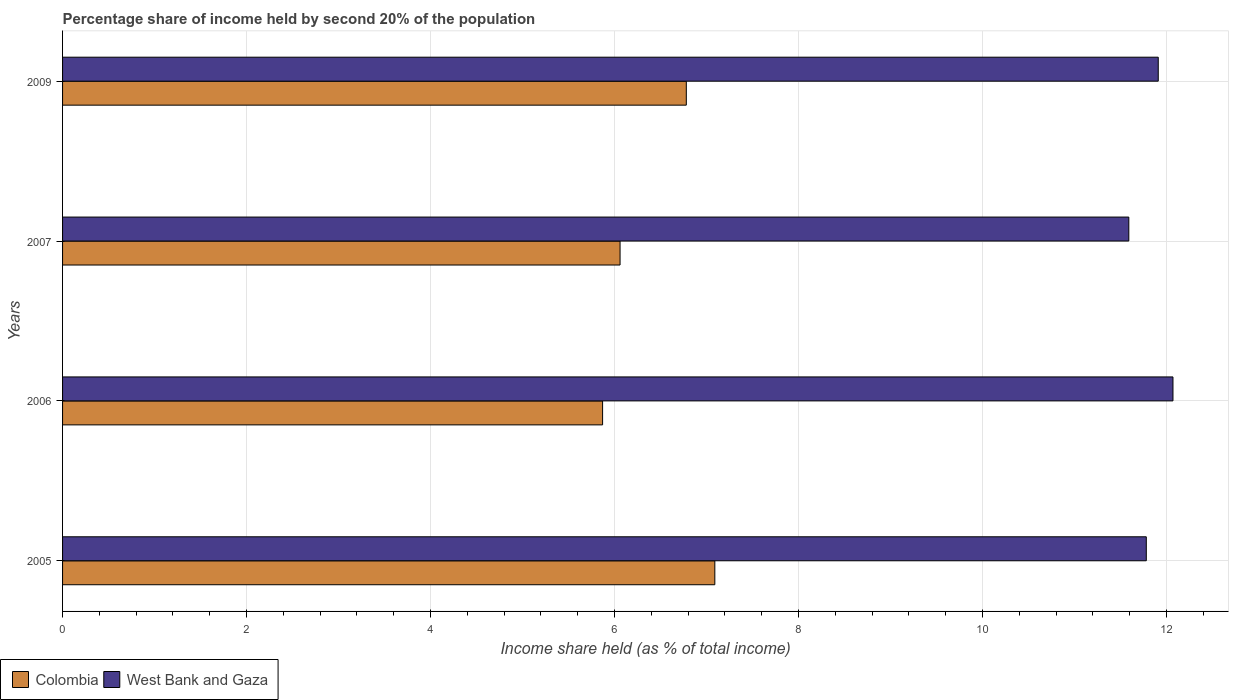How many different coloured bars are there?
Offer a very short reply. 2. What is the label of the 1st group of bars from the top?
Keep it short and to the point. 2009. In how many cases, is the number of bars for a given year not equal to the number of legend labels?
Offer a terse response. 0. What is the share of income held by second 20% of the population in West Bank and Gaza in 2007?
Offer a very short reply. 11.59. Across all years, what is the maximum share of income held by second 20% of the population in Colombia?
Offer a very short reply. 7.09. Across all years, what is the minimum share of income held by second 20% of the population in Colombia?
Make the answer very short. 5.87. In which year was the share of income held by second 20% of the population in Colombia maximum?
Provide a succinct answer. 2005. In which year was the share of income held by second 20% of the population in Colombia minimum?
Your response must be concise. 2006. What is the total share of income held by second 20% of the population in Colombia in the graph?
Offer a terse response. 25.8. What is the difference between the share of income held by second 20% of the population in West Bank and Gaza in 2007 and that in 2009?
Give a very brief answer. -0.32. What is the difference between the share of income held by second 20% of the population in Colombia in 2006 and the share of income held by second 20% of the population in West Bank and Gaza in 2007?
Offer a very short reply. -5.72. What is the average share of income held by second 20% of the population in West Bank and Gaza per year?
Your answer should be very brief. 11.84. In the year 2007, what is the difference between the share of income held by second 20% of the population in West Bank and Gaza and share of income held by second 20% of the population in Colombia?
Offer a very short reply. 5.53. In how many years, is the share of income held by second 20% of the population in Colombia greater than 1.2000000000000002 %?
Provide a succinct answer. 4. What is the ratio of the share of income held by second 20% of the population in Colombia in 2005 to that in 2009?
Provide a short and direct response. 1.05. Is the share of income held by second 20% of the population in Colombia in 2006 less than that in 2009?
Your answer should be compact. Yes. What is the difference between the highest and the second highest share of income held by second 20% of the population in Colombia?
Your answer should be compact. 0.31. What is the difference between the highest and the lowest share of income held by second 20% of the population in West Bank and Gaza?
Keep it short and to the point. 0.48. What does the 2nd bar from the bottom in 2006 represents?
Offer a very short reply. West Bank and Gaza. What is the difference between two consecutive major ticks on the X-axis?
Ensure brevity in your answer.  2. Are the values on the major ticks of X-axis written in scientific E-notation?
Make the answer very short. No. Does the graph contain grids?
Your answer should be very brief. Yes. Where does the legend appear in the graph?
Give a very brief answer. Bottom left. How many legend labels are there?
Offer a very short reply. 2. What is the title of the graph?
Make the answer very short. Percentage share of income held by second 20% of the population. Does "Switzerland" appear as one of the legend labels in the graph?
Provide a succinct answer. No. What is the label or title of the X-axis?
Make the answer very short. Income share held (as % of total income). What is the Income share held (as % of total income) of Colombia in 2005?
Offer a very short reply. 7.09. What is the Income share held (as % of total income) in West Bank and Gaza in 2005?
Make the answer very short. 11.78. What is the Income share held (as % of total income) of Colombia in 2006?
Your answer should be very brief. 5.87. What is the Income share held (as % of total income) of West Bank and Gaza in 2006?
Your response must be concise. 12.07. What is the Income share held (as % of total income) of Colombia in 2007?
Keep it short and to the point. 6.06. What is the Income share held (as % of total income) of West Bank and Gaza in 2007?
Your answer should be very brief. 11.59. What is the Income share held (as % of total income) of Colombia in 2009?
Give a very brief answer. 6.78. What is the Income share held (as % of total income) in West Bank and Gaza in 2009?
Provide a short and direct response. 11.91. Across all years, what is the maximum Income share held (as % of total income) of Colombia?
Ensure brevity in your answer.  7.09. Across all years, what is the maximum Income share held (as % of total income) in West Bank and Gaza?
Provide a succinct answer. 12.07. Across all years, what is the minimum Income share held (as % of total income) in Colombia?
Ensure brevity in your answer.  5.87. Across all years, what is the minimum Income share held (as % of total income) in West Bank and Gaza?
Provide a short and direct response. 11.59. What is the total Income share held (as % of total income) of Colombia in the graph?
Offer a terse response. 25.8. What is the total Income share held (as % of total income) in West Bank and Gaza in the graph?
Offer a terse response. 47.35. What is the difference between the Income share held (as % of total income) of Colombia in 2005 and that in 2006?
Your answer should be compact. 1.22. What is the difference between the Income share held (as % of total income) in West Bank and Gaza in 2005 and that in 2006?
Give a very brief answer. -0.29. What is the difference between the Income share held (as % of total income) of Colombia in 2005 and that in 2007?
Ensure brevity in your answer.  1.03. What is the difference between the Income share held (as % of total income) in West Bank and Gaza in 2005 and that in 2007?
Make the answer very short. 0.19. What is the difference between the Income share held (as % of total income) of Colombia in 2005 and that in 2009?
Keep it short and to the point. 0.31. What is the difference between the Income share held (as % of total income) in West Bank and Gaza in 2005 and that in 2009?
Your answer should be compact. -0.13. What is the difference between the Income share held (as % of total income) of Colombia in 2006 and that in 2007?
Your answer should be very brief. -0.19. What is the difference between the Income share held (as % of total income) in West Bank and Gaza in 2006 and that in 2007?
Ensure brevity in your answer.  0.48. What is the difference between the Income share held (as % of total income) in Colombia in 2006 and that in 2009?
Your answer should be compact. -0.91. What is the difference between the Income share held (as % of total income) of West Bank and Gaza in 2006 and that in 2009?
Offer a terse response. 0.16. What is the difference between the Income share held (as % of total income) in Colombia in 2007 and that in 2009?
Make the answer very short. -0.72. What is the difference between the Income share held (as % of total income) of West Bank and Gaza in 2007 and that in 2009?
Give a very brief answer. -0.32. What is the difference between the Income share held (as % of total income) in Colombia in 2005 and the Income share held (as % of total income) in West Bank and Gaza in 2006?
Provide a short and direct response. -4.98. What is the difference between the Income share held (as % of total income) in Colombia in 2005 and the Income share held (as % of total income) in West Bank and Gaza in 2009?
Provide a short and direct response. -4.82. What is the difference between the Income share held (as % of total income) in Colombia in 2006 and the Income share held (as % of total income) in West Bank and Gaza in 2007?
Your answer should be compact. -5.72. What is the difference between the Income share held (as % of total income) in Colombia in 2006 and the Income share held (as % of total income) in West Bank and Gaza in 2009?
Provide a succinct answer. -6.04. What is the difference between the Income share held (as % of total income) of Colombia in 2007 and the Income share held (as % of total income) of West Bank and Gaza in 2009?
Your response must be concise. -5.85. What is the average Income share held (as % of total income) of Colombia per year?
Make the answer very short. 6.45. What is the average Income share held (as % of total income) in West Bank and Gaza per year?
Your response must be concise. 11.84. In the year 2005, what is the difference between the Income share held (as % of total income) of Colombia and Income share held (as % of total income) of West Bank and Gaza?
Provide a short and direct response. -4.69. In the year 2007, what is the difference between the Income share held (as % of total income) in Colombia and Income share held (as % of total income) in West Bank and Gaza?
Provide a short and direct response. -5.53. In the year 2009, what is the difference between the Income share held (as % of total income) of Colombia and Income share held (as % of total income) of West Bank and Gaza?
Offer a terse response. -5.13. What is the ratio of the Income share held (as % of total income) of Colombia in 2005 to that in 2006?
Your answer should be very brief. 1.21. What is the ratio of the Income share held (as % of total income) of West Bank and Gaza in 2005 to that in 2006?
Ensure brevity in your answer.  0.98. What is the ratio of the Income share held (as % of total income) in Colombia in 2005 to that in 2007?
Keep it short and to the point. 1.17. What is the ratio of the Income share held (as % of total income) of West Bank and Gaza in 2005 to that in 2007?
Keep it short and to the point. 1.02. What is the ratio of the Income share held (as % of total income) in Colombia in 2005 to that in 2009?
Give a very brief answer. 1.05. What is the ratio of the Income share held (as % of total income) in Colombia in 2006 to that in 2007?
Keep it short and to the point. 0.97. What is the ratio of the Income share held (as % of total income) of West Bank and Gaza in 2006 to that in 2007?
Your response must be concise. 1.04. What is the ratio of the Income share held (as % of total income) of Colombia in 2006 to that in 2009?
Your response must be concise. 0.87. What is the ratio of the Income share held (as % of total income) in West Bank and Gaza in 2006 to that in 2009?
Give a very brief answer. 1.01. What is the ratio of the Income share held (as % of total income) of Colombia in 2007 to that in 2009?
Provide a succinct answer. 0.89. What is the ratio of the Income share held (as % of total income) in West Bank and Gaza in 2007 to that in 2009?
Keep it short and to the point. 0.97. What is the difference between the highest and the second highest Income share held (as % of total income) in Colombia?
Provide a succinct answer. 0.31. What is the difference between the highest and the second highest Income share held (as % of total income) of West Bank and Gaza?
Your answer should be very brief. 0.16. What is the difference between the highest and the lowest Income share held (as % of total income) in Colombia?
Your answer should be compact. 1.22. What is the difference between the highest and the lowest Income share held (as % of total income) of West Bank and Gaza?
Provide a succinct answer. 0.48. 